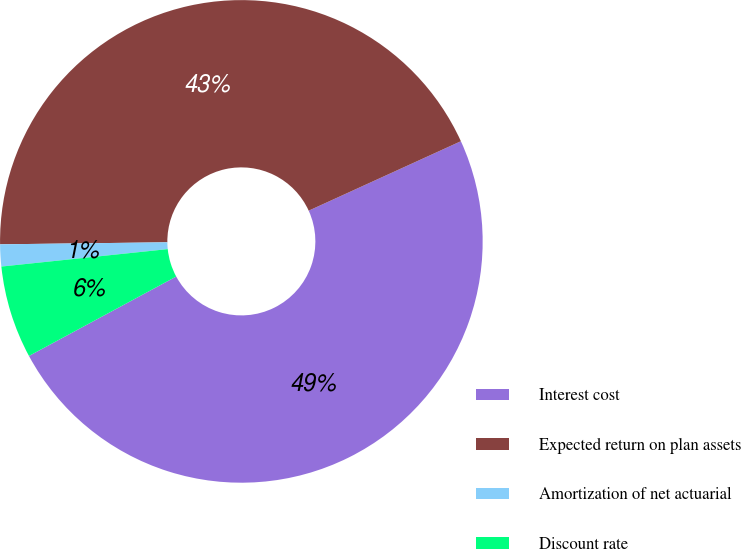Convert chart. <chart><loc_0><loc_0><loc_500><loc_500><pie_chart><fcel>Interest cost<fcel>Expected return on plan assets<fcel>Amortization of net actuarial<fcel>Discount rate<nl><fcel>48.94%<fcel>43.38%<fcel>1.47%<fcel>6.21%<nl></chart> 